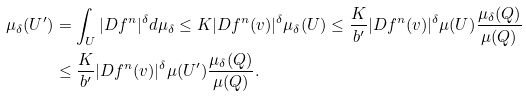<formula> <loc_0><loc_0><loc_500><loc_500>\mu _ { \delta } ( U ^ { \prime } ) & = \int _ { U } | D f ^ { n } | ^ { \delta } d \mu _ { \delta } \leq K | D f ^ { n } ( v ) | ^ { \delta } \mu _ { \delta } ( U ) \leq \frac { K } { b ^ { \prime } } | D f ^ { n } ( v ) | ^ { \delta } \mu ( U ) \frac { \mu _ { \delta } ( Q ) } { \mu ( Q ) } \\ & \leq \frac { K } { b ^ { \prime } } | D f ^ { n } ( v ) | ^ { \delta } \mu ( U ^ { \prime } ) \frac { \mu _ { \delta } ( Q ) } { \mu ( Q ) } .</formula> 